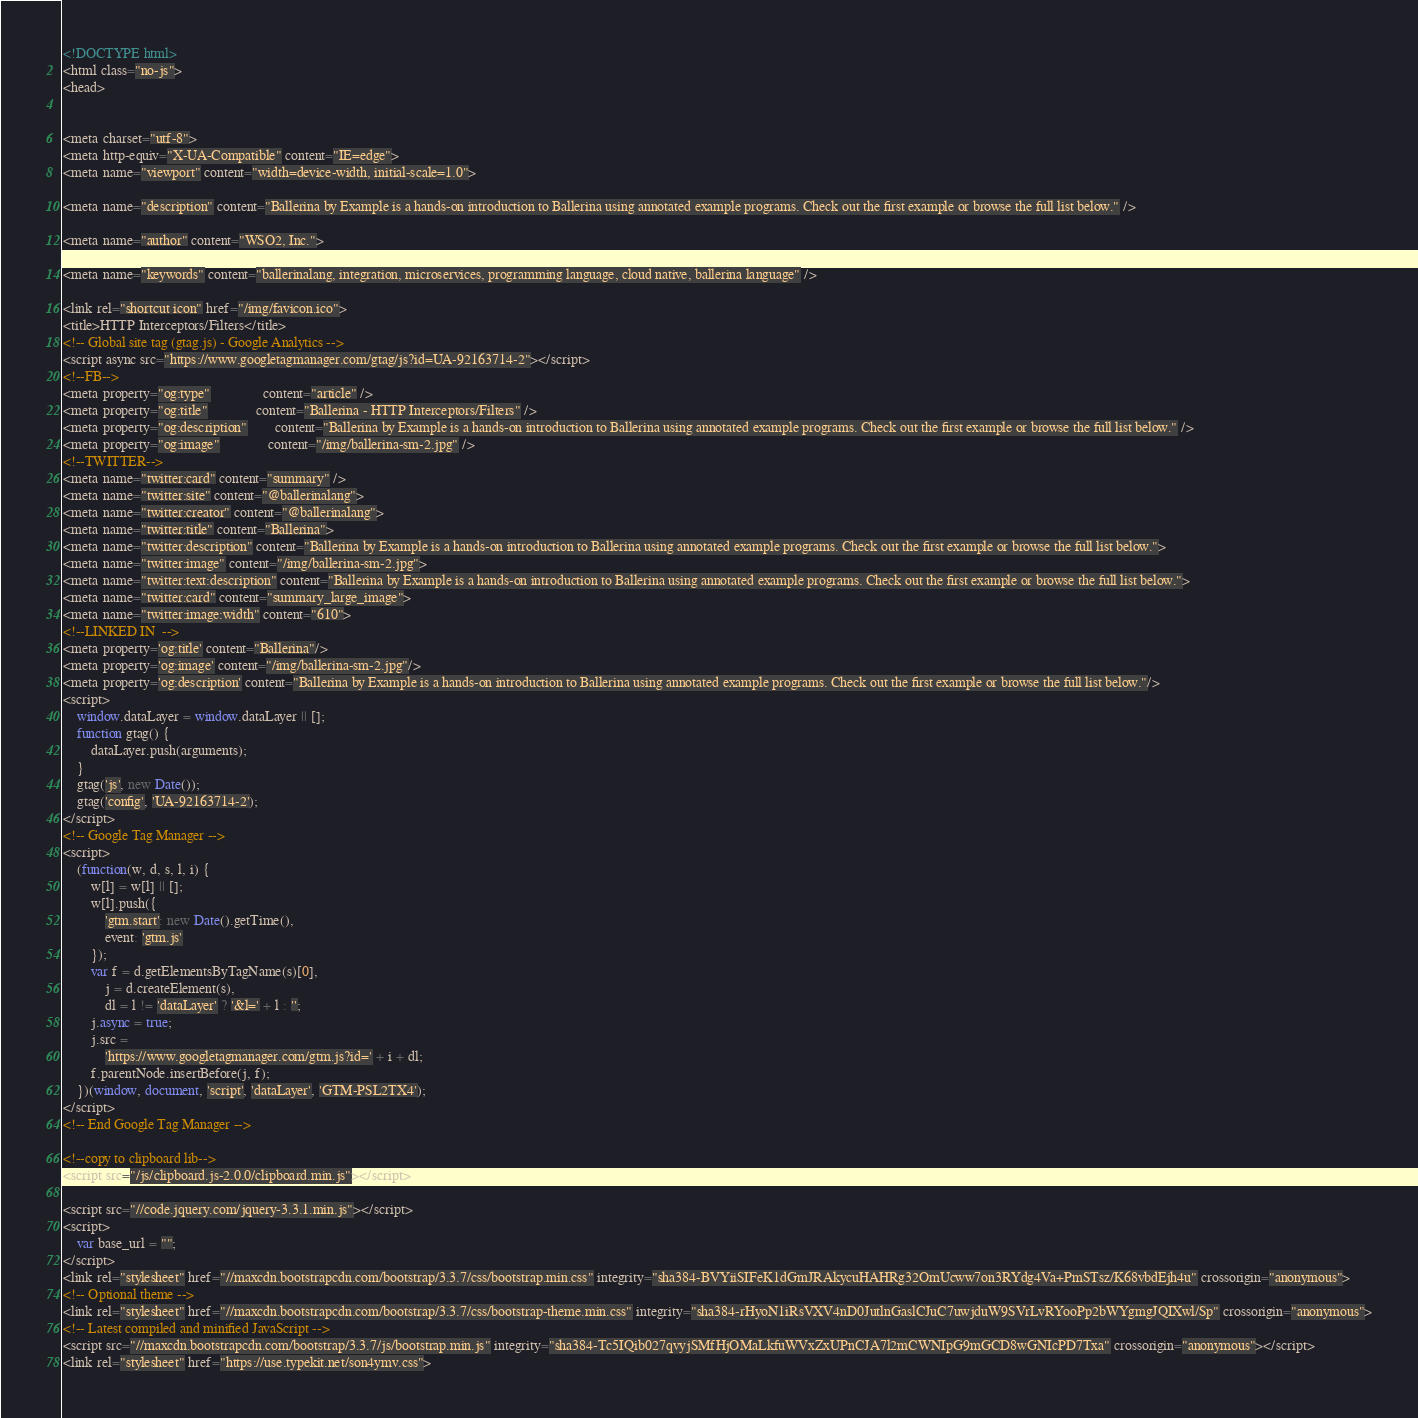<code> <loc_0><loc_0><loc_500><loc_500><_HTML_>

<!DOCTYPE html>
<html class="no-js">
<head>
    

<meta charset="utf-8">
<meta http-equiv="X-UA-Compatible" content="IE=edge">
<meta name="viewport" content="width=device-width, initial-scale=1.0">

<meta name="description" content="Ballerina by Example is a hands-on introduction to Ballerina using annotated example programs. Check out the first example or browse the full list below." />

<meta name="author" content="WSO2, Inc.">

<meta name="keywords" content="ballerinalang, integration, microservices, programming language, cloud native, ballerina language" />

<link rel="shortcut icon" href="/img/favicon.ico">
<title>HTTP Interceptors/Filters</title>
<!-- Global site tag (gtag.js) - Google Analytics -->
<script async src="https://www.googletagmanager.com/gtag/js?id=UA-92163714-2"></script>
<!--FB-->
<meta property="og:type"               content="article" />
<meta property="og:title"              content="Ballerina - HTTP Interceptors/Filters" />
<meta property="og:description"        content="Ballerina by Example is a hands-on introduction to Ballerina using annotated example programs. Check out the first example or browse the full list below." />
<meta property="og:image"              content="/img/ballerina-sm-2.jpg" />
<!--TWITTER-->
<meta name="twitter:card" content="summary" />
<meta name="twitter:site" content="@ballerinalang">
<meta name="twitter:creator" content="@ballerinalang">
<meta name="twitter:title" content="Ballerina">
<meta name="twitter:description" content="Ballerina by Example is a hands-on introduction to Ballerina using annotated example programs. Check out the first example or browse the full list below.">
<meta name="twitter:image" content="/img/ballerina-sm-2.jpg">
<meta name="twitter:text:description" content="Ballerina by Example is a hands-on introduction to Ballerina using annotated example programs. Check out the first example or browse the full list below.">
<meta name="twitter:card" content="summary_large_image">
<meta name="twitter:image:width" content="610">
<!--LINKED IN  -->
<meta property='og:title' content="Ballerina"/>
<meta property='og:image' content="/img/ballerina-sm-2.jpg"/>
<meta property='og:description' content="Ballerina by Example is a hands-on introduction to Ballerina using annotated example programs. Check out the first example or browse the full list below."/>
<script>
    window.dataLayer = window.dataLayer || [];
    function gtag() {
        dataLayer.push(arguments);
    }
    gtag('js', new Date());
    gtag('config', 'UA-92163714-2');
</script>
<!-- Google Tag Manager -->
<script>
    (function(w, d, s, l, i) {
        w[l] = w[l] || [];
        w[l].push({
            'gtm.start': new Date().getTime(),
            event: 'gtm.js'
        });
        var f = d.getElementsByTagName(s)[0],
            j = d.createElement(s),
            dl = l != 'dataLayer' ? '&l=' + l : '';
        j.async = true;
        j.src =
            'https://www.googletagmanager.com/gtm.js?id=' + i + dl;
        f.parentNode.insertBefore(j, f);
    })(window, document, 'script', 'dataLayer', 'GTM-PSL2TX4');
</script>
<!-- End Google Tag Manager -->

<!--copy to clipboard lib-->
<script src="/js/clipboard.js-2.0.0/clipboard.min.js"></script>

<script src="//code.jquery.com/jquery-3.3.1.min.js"></script>
<script>
    var base_url = "";
</script>
<link rel="stylesheet" href="//maxcdn.bootstrapcdn.com/bootstrap/3.3.7/css/bootstrap.min.css" integrity="sha384-BVYiiSIFeK1dGmJRAkycuHAHRg32OmUcww7on3RYdg4Va+PmSTsz/K68vbdEjh4u" crossorigin="anonymous">
<!-- Optional theme -->
<link rel="stylesheet" href="//maxcdn.bootstrapcdn.com/bootstrap/3.3.7/css/bootstrap-theme.min.css" integrity="sha384-rHyoN1iRsVXV4nD0JutlnGaslCJuC7uwjduW9SVrLvRYooPp2bWYgmgJQIXwl/Sp" crossorigin="anonymous">
<!-- Latest compiled and minified JavaScript -->
<script src="//maxcdn.bootstrapcdn.com/bootstrap/3.3.7/js/bootstrap.min.js" integrity="sha384-Tc5IQib027qvyjSMfHjOMaLkfuWVxZxUPnCJA7l2mCWNIpG9mGCD8wGNIcPD7Txa" crossorigin="anonymous"></script>
<link rel="stylesheet" href="https://use.typekit.net/son4ymv.css">
</code> 